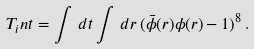<formula> <loc_0><loc_0><loc_500><loc_500>T _ { i } n t = \int \, d t \int \, d r \, ( \bar { \phi } ( r ) \phi ( r ) - 1 ) ^ { 8 } \, .</formula> 